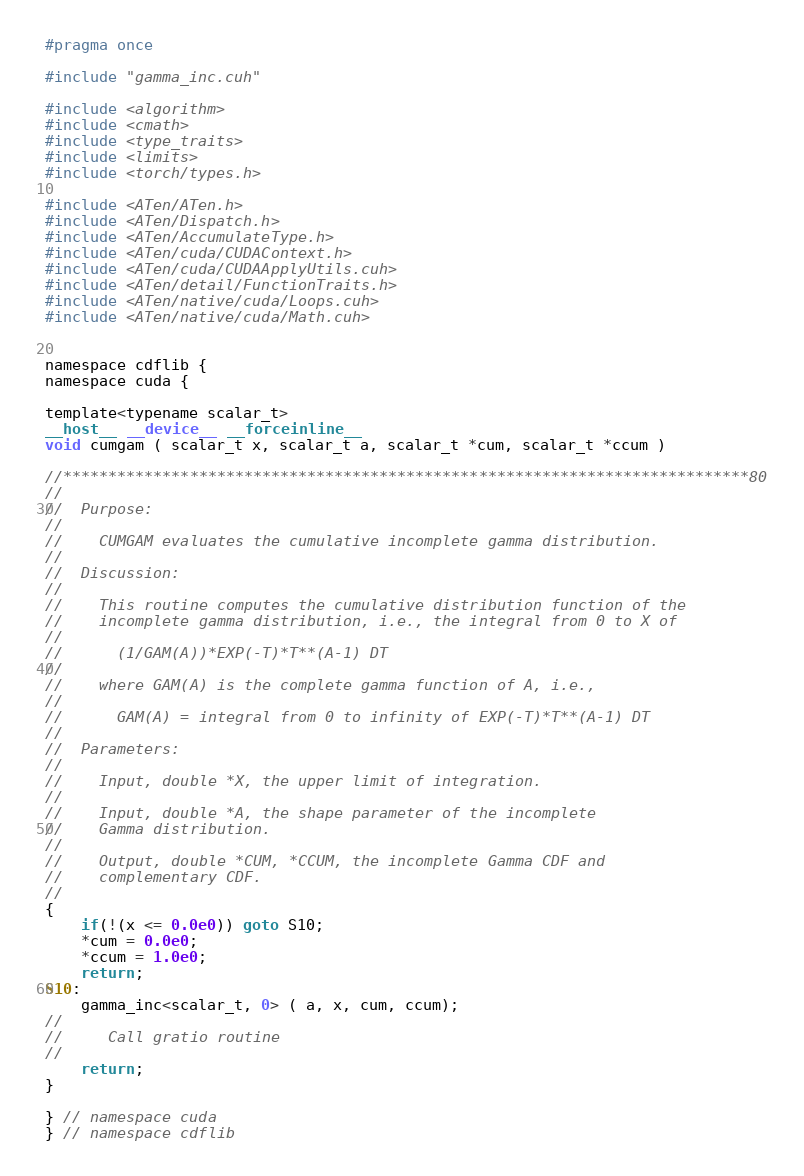Convert code to text. <code><loc_0><loc_0><loc_500><loc_500><_Cuda_>#pragma once

#include "gamma_inc.cuh"

#include <algorithm>
#include <cmath>
#include <type_traits>
#include <limits>
#include <torch/types.h>

#include <ATen/ATen.h>
#include <ATen/Dispatch.h>
#include <ATen/AccumulateType.h>
#include <ATen/cuda/CUDAContext.h>
#include <ATen/cuda/CUDAApplyUtils.cuh>
#include <ATen/detail/FunctionTraits.h>
#include <ATen/native/cuda/Loops.cuh>
#include <ATen/native/cuda/Math.cuh>


namespace cdflib {
namespace cuda {

template<typename scalar_t>
__host__ __device__ __forceinline__
void cumgam ( scalar_t x, scalar_t a, scalar_t *cum, scalar_t *ccum )

//****************************************************************************80
//
//  Purpose:
//
//    CUMGAM evaluates the cumulative incomplete gamma distribution.
//
//  Discussion:
//
//    This routine computes the cumulative distribution function of the
//    incomplete gamma distribution, i.e., the integral from 0 to X of
//
//      (1/GAM(A))*EXP(-T)*T**(A-1) DT
//
//    where GAM(A) is the complete gamma function of A, i.e.,
//
//      GAM(A) = integral from 0 to infinity of EXP(-T)*T**(A-1) DT
//
//  Parameters:
//
//    Input, double *X, the upper limit of integration.
//
//    Input, double *A, the shape parameter of the incomplete
//    Gamma distribution.
//
//    Output, double *CUM, *CCUM, the incomplete Gamma CDF and
//    complementary CDF.
//
{
    if(!(x <= 0.0e0)) goto S10;
    *cum = 0.0e0;
    *ccum = 1.0e0;
    return;
S10:
    gamma_inc<scalar_t, 0> ( a, x, cum, ccum);
//
//     Call gratio routine
//
    return;
}

} // namespace cuda
} // namespace cdflib
</code> 